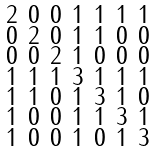<formula> <loc_0><loc_0><loc_500><loc_500>\begin{smallmatrix} 2 & 0 & 0 & 1 & 1 & 1 & 1 \\ 0 & 2 & 0 & 1 & 1 & 0 & 0 \\ 0 & 0 & 2 & 1 & 0 & 0 & 0 \\ 1 & 1 & 1 & 3 & 1 & 1 & 1 \\ 1 & 1 & 0 & 1 & 3 & 1 & 0 \\ 1 & 0 & 0 & 1 & 1 & 3 & 1 \\ 1 & 0 & 0 & 1 & 0 & 1 & 3 \end{smallmatrix}</formula> 